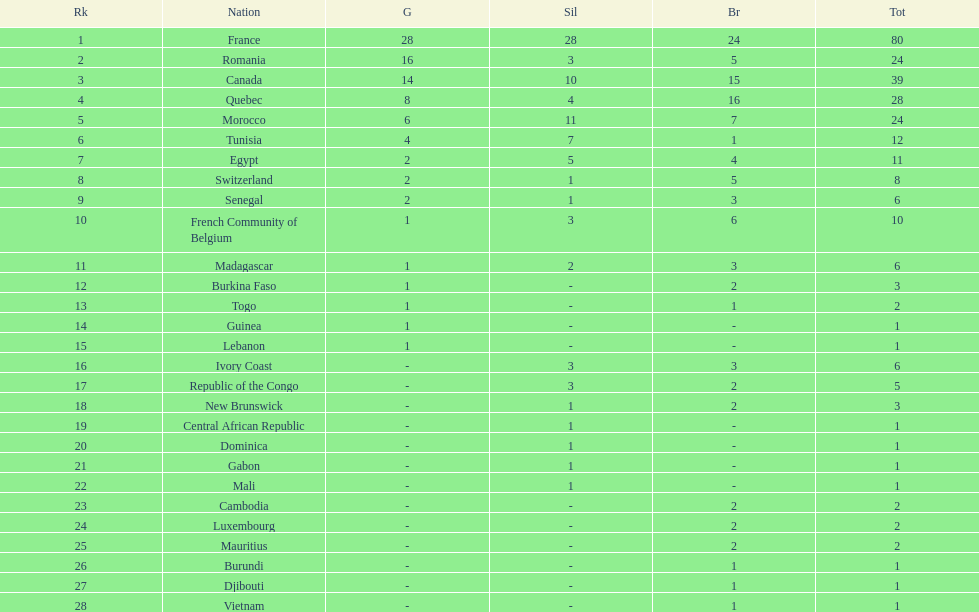How many counties have at least one silver medal? 18. 